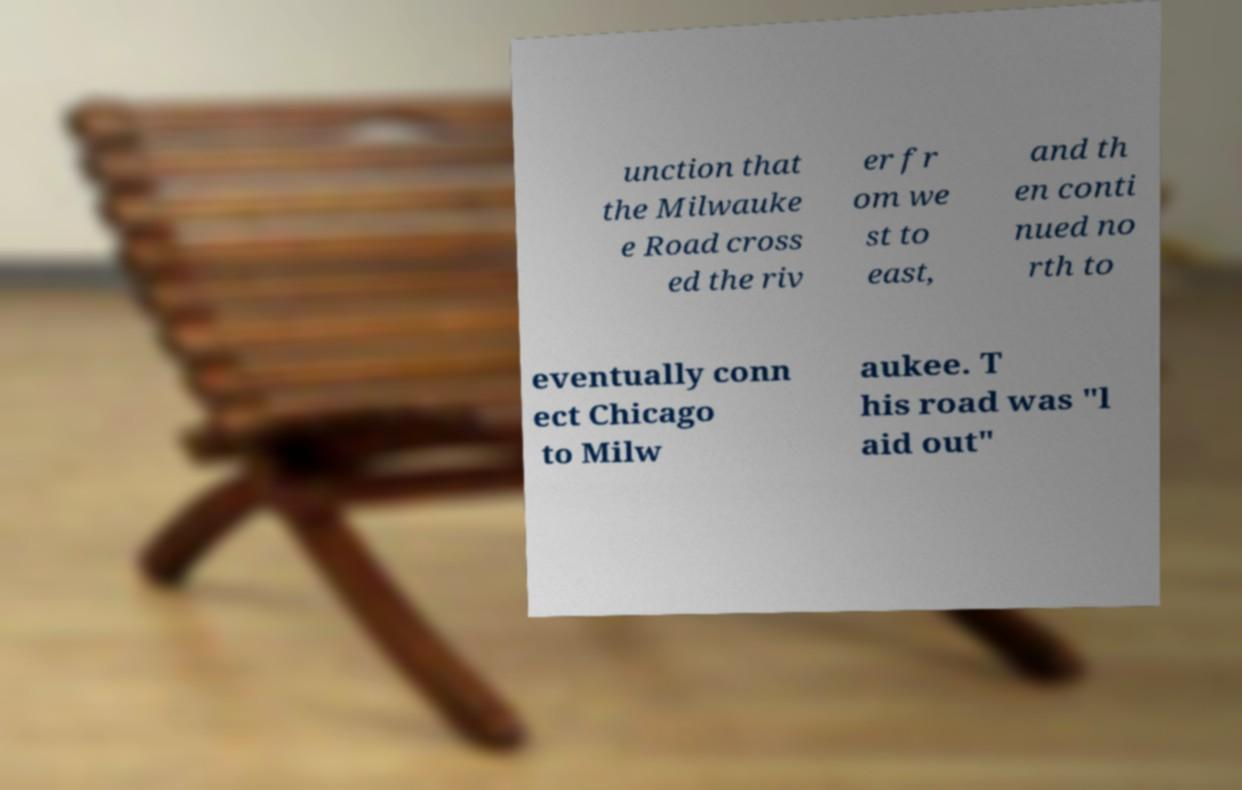For documentation purposes, I need the text within this image transcribed. Could you provide that? unction that the Milwauke e Road cross ed the riv er fr om we st to east, and th en conti nued no rth to eventually conn ect Chicago to Milw aukee. T his road was "l aid out" 